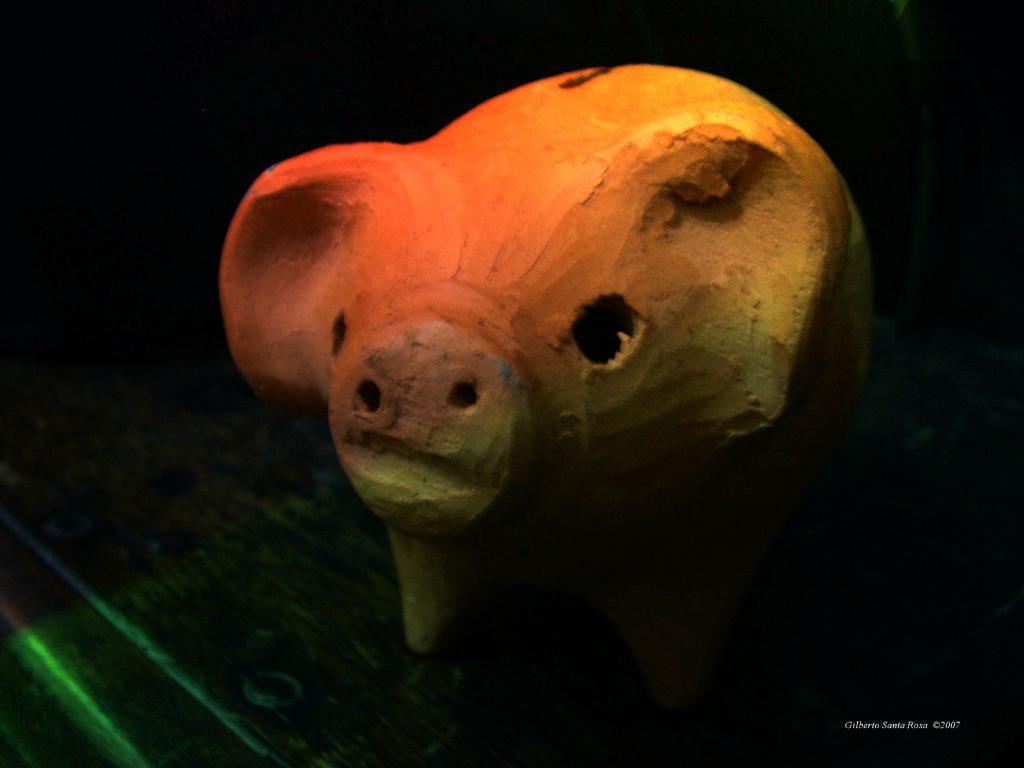How would you summarize this image in a sentence or two? In the center of the image we can see a piggy bank placed on the table. 